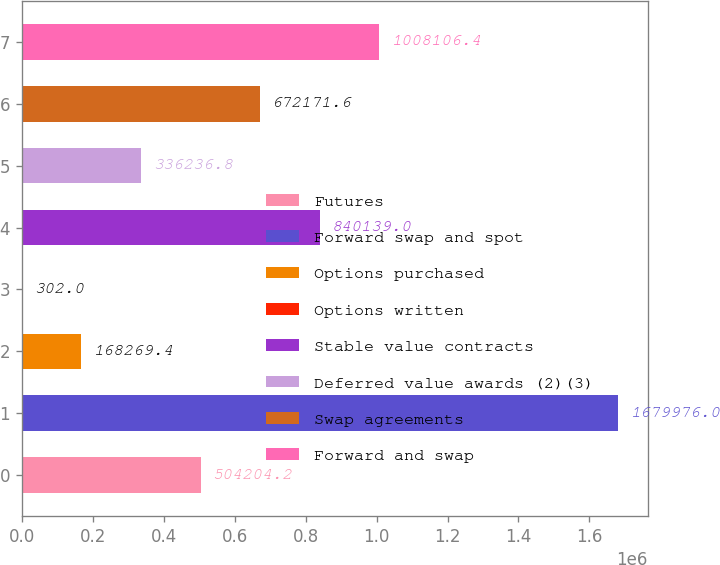Convert chart to OTSL. <chart><loc_0><loc_0><loc_500><loc_500><bar_chart><fcel>Futures<fcel>Forward swap and spot<fcel>Options purchased<fcel>Options written<fcel>Stable value contracts<fcel>Deferred value awards (2)(3)<fcel>Swap agreements<fcel>Forward and swap<nl><fcel>504204<fcel>1.67998e+06<fcel>168269<fcel>302<fcel>840139<fcel>336237<fcel>672172<fcel>1.00811e+06<nl></chart> 